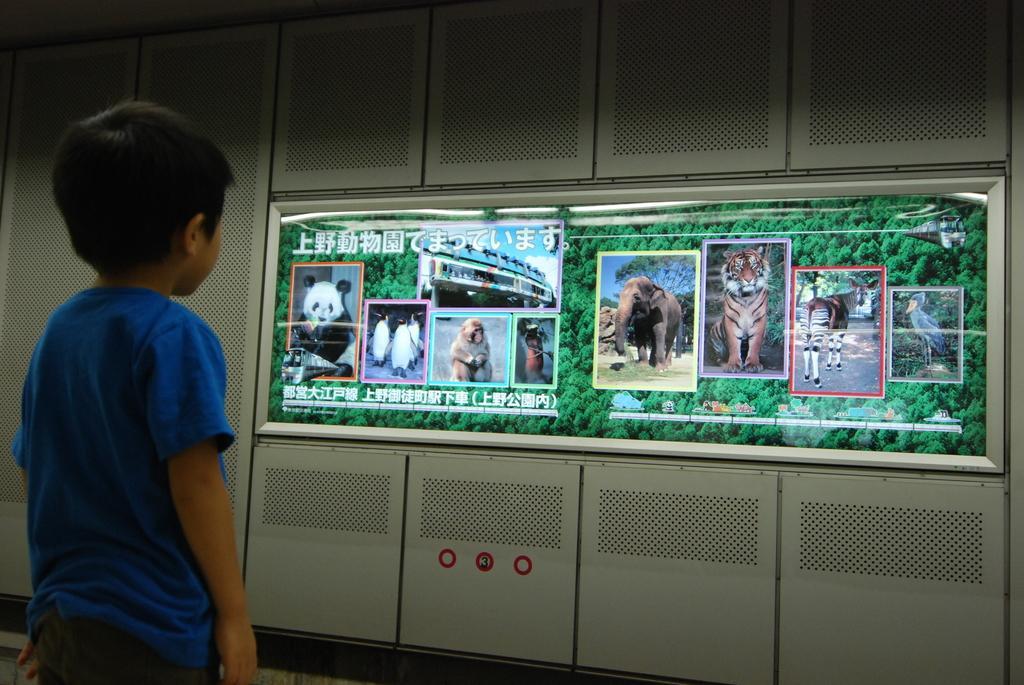Please provide a concise description of this image. As we can see in the image there are cupboards, screen and on the left side there is a boy wearing blue color t shirt. On screen there are trees and different types of animals. 